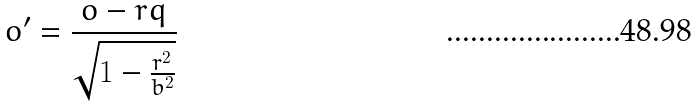<formula> <loc_0><loc_0><loc_500><loc_500>o ^ { \prime } = \frac { o - r q } { \sqrt { 1 - \frac { r ^ { 2 } } { b ^ { 2 } } } }</formula> 